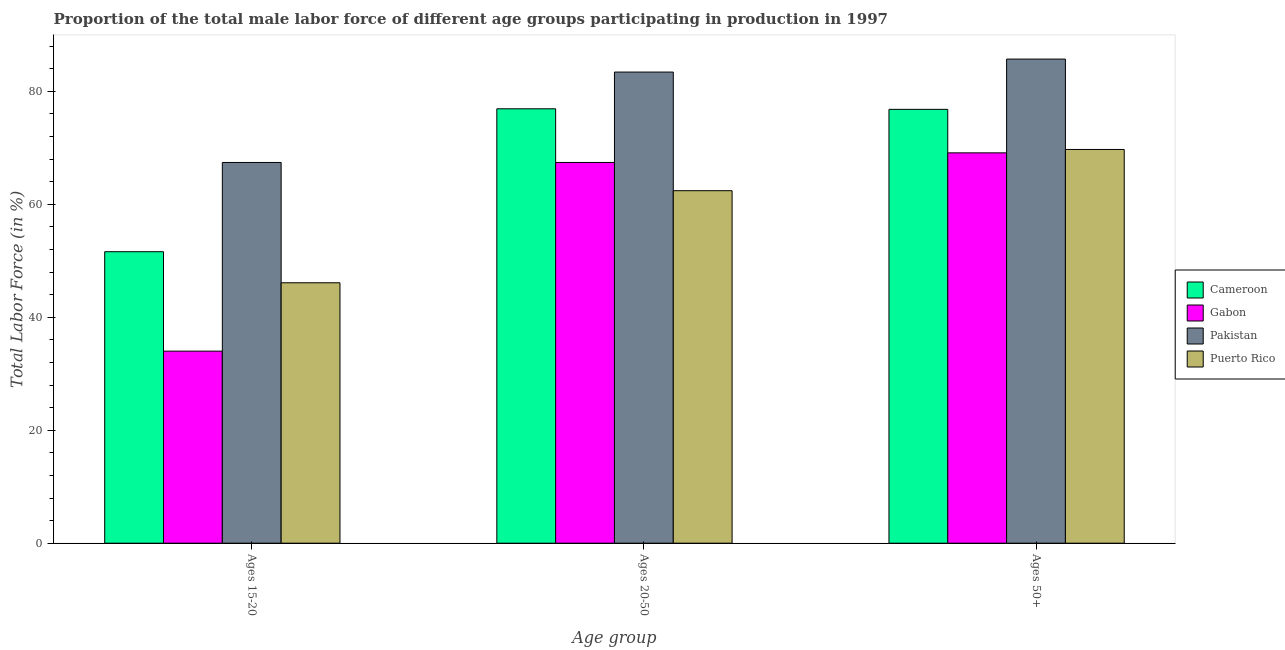How many groups of bars are there?
Provide a succinct answer. 3. What is the label of the 2nd group of bars from the left?
Give a very brief answer. Ages 20-50. What is the percentage of male labor force within the age group 20-50 in Cameroon?
Make the answer very short. 76.9. Across all countries, what is the maximum percentage of male labor force within the age group 15-20?
Give a very brief answer. 67.4. Across all countries, what is the minimum percentage of male labor force within the age group 20-50?
Ensure brevity in your answer.  62.4. In which country was the percentage of male labor force above age 50 minimum?
Give a very brief answer. Gabon. What is the total percentage of male labor force above age 50 in the graph?
Provide a short and direct response. 301.3. What is the difference between the percentage of male labor force within the age group 20-50 in Gabon and that in Puerto Rico?
Provide a short and direct response. 5. What is the difference between the percentage of male labor force within the age group 20-50 in Pakistan and the percentage of male labor force within the age group 15-20 in Puerto Rico?
Keep it short and to the point. 37.3. What is the average percentage of male labor force within the age group 20-50 per country?
Make the answer very short. 72.53. What is the difference between the percentage of male labor force within the age group 15-20 and percentage of male labor force within the age group 20-50 in Cameroon?
Give a very brief answer. -25.3. In how many countries, is the percentage of male labor force within the age group 15-20 greater than 24 %?
Keep it short and to the point. 4. What is the ratio of the percentage of male labor force above age 50 in Gabon to that in Puerto Rico?
Your answer should be compact. 0.99. Is the percentage of male labor force within the age group 20-50 in Pakistan less than that in Cameroon?
Offer a terse response. No. Is the difference between the percentage of male labor force within the age group 15-20 in Cameroon and Pakistan greater than the difference between the percentage of male labor force above age 50 in Cameroon and Pakistan?
Offer a terse response. No. What is the difference between the highest and the second highest percentage of male labor force within the age group 20-50?
Your response must be concise. 6.5. What is the difference between the highest and the lowest percentage of male labor force above age 50?
Offer a terse response. 16.6. In how many countries, is the percentage of male labor force within the age group 15-20 greater than the average percentage of male labor force within the age group 15-20 taken over all countries?
Your answer should be very brief. 2. Is the sum of the percentage of male labor force above age 50 in Pakistan and Gabon greater than the maximum percentage of male labor force within the age group 20-50 across all countries?
Give a very brief answer. Yes. What does the 1st bar from the right in Ages 50+ represents?
Provide a succinct answer. Puerto Rico. Is it the case that in every country, the sum of the percentage of male labor force within the age group 15-20 and percentage of male labor force within the age group 20-50 is greater than the percentage of male labor force above age 50?
Offer a very short reply. Yes. Are all the bars in the graph horizontal?
Give a very brief answer. No. What is the difference between two consecutive major ticks on the Y-axis?
Provide a short and direct response. 20. Does the graph contain grids?
Offer a very short reply. No. What is the title of the graph?
Provide a succinct answer. Proportion of the total male labor force of different age groups participating in production in 1997. Does "Ukraine" appear as one of the legend labels in the graph?
Your answer should be compact. No. What is the label or title of the X-axis?
Your answer should be very brief. Age group. What is the Total Labor Force (in %) of Cameroon in Ages 15-20?
Ensure brevity in your answer.  51.6. What is the Total Labor Force (in %) of Gabon in Ages 15-20?
Offer a terse response. 34. What is the Total Labor Force (in %) of Pakistan in Ages 15-20?
Offer a terse response. 67.4. What is the Total Labor Force (in %) in Puerto Rico in Ages 15-20?
Offer a very short reply. 46.1. What is the Total Labor Force (in %) of Cameroon in Ages 20-50?
Ensure brevity in your answer.  76.9. What is the Total Labor Force (in %) of Gabon in Ages 20-50?
Provide a succinct answer. 67.4. What is the Total Labor Force (in %) of Pakistan in Ages 20-50?
Keep it short and to the point. 83.4. What is the Total Labor Force (in %) in Puerto Rico in Ages 20-50?
Offer a terse response. 62.4. What is the Total Labor Force (in %) of Cameroon in Ages 50+?
Offer a terse response. 76.8. What is the Total Labor Force (in %) of Gabon in Ages 50+?
Offer a very short reply. 69.1. What is the Total Labor Force (in %) in Pakistan in Ages 50+?
Your answer should be very brief. 85.7. What is the Total Labor Force (in %) in Puerto Rico in Ages 50+?
Ensure brevity in your answer.  69.7. Across all Age group, what is the maximum Total Labor Force (in %) of Cameroon?
Provide a short and direct response. 76.9. Across all Age group, what is the maximum Total Labor Force (in %) in Gabon?
Ensure brevity in your answer.  69.1. Across all Age group, what is the maximum Total Labor Force (in %) of Pakistan?
Offer a terse response. 85.7. Across all Age group, what is the maximum Total Labor Force (in %) in Puerto Rico?
Your response must be concise. 69.7. Across all Age group, what is the minimum Total Labor Force (in %) in Cameroon?
Provide a succinct answer. 51.6. Across all Age group, what is the minimum Total Labor Force (in %) of Gabon?
Give a very brief answer. 34. Across all Age group, what is the minimum Total Labor Force (in %) in Pakistan?
Offer a very short reply. 67.4. Across all Age group, what is the minimum Total Labor Force (in %) of Puerto Rico?
Provide a succinct answer. 46.1. What is the total Total Labor Force (in %) in Cameroon in the graph?
Offer a terse response. 205.3. What is the total Total Labor Force (in %) of Gabon in the graph?
Ensure brevity in your answer.  170.5. What is the total Total Labor Force (in %) of Pakistan in the graph?
Provide a succinct answer. 236.5. What is the total Total Labor Force (in %) of Puerto Rico in the graph?
Keep it short and to the point. 178.2. What is the difference between the Total Labor Force (in %) of Cameroon in Ages 15-20 and that in Ages 20-50?
Offer a terse response. -25.3. What is the difference between the Total Labor Force (in %) of Gabon in Ages 15-20 and that in Ages 20-50?
Provide a short and direct response. -33.4. What is the difference between the Total Labor Force (in %) in Puerto Rico in Ages 15-20 and that in Ages 20-50?
Your answer should be compact. -16.3. What is the difference between the Total Labor Force (in %) in Cameroon in Ages 15-20 and that in Ages 50+?
Keep it short and to the point. -25.2. What is the difference between the Total Labor Force (in %) of Gabon in Ages 15-20 and that in Ages 50+?
Your response must be concise. -35.1. What is the difference between the Total Labor Force (in %) of Pakistan in Ages 15-20 and that in Ages 50+?
Offer a terse response. -18.3. What is the difference between the Total Labor Force (in %) of Puerto Rico in Ages 15-20 and that in Ages 50+?
Your answer should be compact. -23.6. What is the difference between the Total Labor Force (in %) of Cameroon in Ages 20-50 and that in Ages 50+?
Make the answer very short. 0.1. What is the difference between the Total Labor Force (in %) of Gabon in Ages 20-50 and that in Ages 50+?
Offer a very short reply. -1.7. What is the difference between the Total Labor Force (in %) in Puerto Rico in Ages 20-50 and that in Ages 50+?
Give a very brief answer. -7.3. What is the difference between the Total Labor Force (in %) of Cameroon in Ages 15-20 and the Total Labor Force (in %) of Gabon in Ages 20-50?
Ensure brevity in your answer.  -15.8. What is the difference between the Total Labor Force (in %) of Cameroon in Ages 15-20 and the Total Labor Force (in %) of Pakistan in Ages 20-50?
Ensure brevity in your answer.  -31.8. What is the difference between the Total Labor Force (in %) in Cameroon in Ages 15-20 and the Total Labor Force (in %) in Puerto Rico in Ages 20-50?
Ensure brevity in your answer.  -10.8. What is the difference between the Total Labor Force (in %) in Gabon in Ages 15-20 and the Total Labor Force (in %) in Pakistan in Ages 20-50?
Your response must be concise. -49.4. What is the difference between the Total Labor Force (in %) in Gabon in Ages 15-20 and the Total Labor Force (in %) in Puerto Rico in Ages 20-50?
Your response must be concise. -28.4. What is the difference between the Total Labor Force (in %) of Pakistan in Ages 15-20 and the Total Labor Force (in %) of Puerto Rico in Ages 20-50?
Your answer should be very brief. 5. What is the difference between the Total Labor Force (in %) of Cameroon in Ages 15-20 and the Total Labor Force (in %) of Gabon in Ages 50+?
Offer a terse response. -17.5. What is the difference between the Total Labor Force (in %) in Cameroon in Ages 15-20 and the Total Labor Force (in %) in Pakistan in Ages 50+?
Make the answer very short. -34.1. What is the difference between the Total Labor Force (in %) in Cameroon in Ages 15-20 and the Total Labor Force (in %) in Puerto Rico in Ages 50+?
Provide a short and direct response. -18.1. What is the difference between the Total Labor Force (in %) of Gabon in Ages 15-20 and the Total Labor Force (in %) of Pakistan in Ages 50+?
Your answer should be very brief. -51.7. What is the difference between the Total Labor Force (in %) of Gabon in Ages 15-20 and the Total Labor Force (in %) of Puerto Rico in Ages 50+?
Give a very brief answer. -35.7. What is the difference between the Total Labor Force (in %) in Pakistan in Ages 15-20 and the Total Labor Force (in %) in Puerto Rico in Ages 50+?
Keep it short and to the point. -2.3. What is the difference between the Total Labor Force (in %) of Cameroon in Ages 20-50 and the Total Labor Force (in %) of Gabon in Ages 50+?
Ensure brevity in your answer.  7.8. What is the difference between the Total Labor Force (in %) of Cameroon in Ages 20-50 and the Total Labor Force (in %) of Pakistan in Ages 50+?
Your answer should be compact. -8.8. What is the difference between the Total Labor Force (in %) of Gabon in Ages 20-50 and the Total Labor Force (in %) of Pakistan in Ages 50+?
Provide a short and direct response. -18.3. What is the average Total Labor Force (in %) in Cameroon per Age group?
Provide a succinct answer. 68.43. What is the average Total Labor Force (in %) of Gabon per Age group?
Provide a succinct answer. 56.83. What is the average Total Labor Force (in %) of Pakistan per Age group?
Provide a short and direct response. 78.83. What is the average Total Labor Force (in %) in Puerto Rico per Age group?
Offer a terse response. 59.4. What is the difference between the Total Labor Force (in %) of Cameroon and Total Labor Force (in %) of Pakistan in Ages 15-20?
Your answer should be very brief. -15.8. What is the difference between the Total Labor Force (in %) in Gabon and Total Labor Force (in %) in Pakistan in Ages 15-20?
Your answer should be compact. -33.4. What is the difference between the Total Labor Force (in %) of Gabon and Total Labor Force (in %) of Puerto Rico in Ages 15-20?
Offer a terse response. -12.1. What is the difference between the Total Labor Force (in %) of Pakistan and Total Labor Force (in %) of Puerto Rico in Ages 15-20?
Provide a short and direct response. 21.3. What is the difference between the Total Labor Force (in %) in Gabon and Total Labor Force (in %) in Pakistan in Ages 50+?
Provide a succinct answer. -16.6. What is the difference between the Total Labor Force (in %) of Gabon and Total Labor Force (in %) of Puerto Rico in Ages 50+?
Provide a short and direct response. -0.6. What is the difference between the Total Labor Force (in %) in Pakistan and Total Labor Force (in %) in Puerto Rico in Ages 50+?
Provide a succinct answer. 16. What is the ratio of the Total Labor Force (in %) of Cameroon in Ages 15-20 to that in Ages 20-50?
Keep it short and to the point. 0.67. What is the ratio of the Total Labor Force (in %) of Gabon in Ages 15-20 to that in Ages 20-50?
Offer a very short reply. 0.5. What is the ratio of the Total Labor Force (in %) of Pakistan in Ages 15-20 to that in Ages 20-50?
Offer a very short reply. 0.81. What is the ratio of the Total Labor Force (in %) in Puerto Rico in Ages 15-20 to that in Ages 20-50?
Offer a terse response. 0.74. What is the ratio of the Total Labor Force (in %) in Cameroon in Ages 15-20 to that in Ages 50+?
Keep it short and to the point. 0.67. What is the ratio of the Total Labor Force (in %) in Gabon in Ages 15-20 to that in Ages 50+?
Offer a very short reply. 0.49. What is the ratio of the Total Labor Force (in %) of Pakistan in Ages 15-20 to that in Ages 50+?
Keep it short and to the point. 0.79. What is the ratio of the Total Labor Force (in %) of Puerto Rico in Ages 15-20 to that in Ages 50+?
Your answer should be compact. 0.66. What is the ratio of the Total Labor Force (in %) of Cameroon in Ages 20-50 to that in Ages 50+?
Give a very brief answer. 1. What is the ratio of the Total Labor Force (in %) of Gabon in Ages 20-50 to that in Ages 50+?
Give a very brief answer. 0.98. What is the ratio of the Total Labor Force (in %) in Pakistan in Ages 20-50 to that in Ages 50+?
Offer a terse response. 0.97. What is the ratio of the Total Labor Force (in %) in Puerto Rico in Ages 20-50 to that in Ages 50+?
Make the answer very short. 0.9. What is the difference between the highest and the second highest Total Labor Force (in %) of Cameroon?
Give a very brief answer. 0.1. What is the difference between the highest and the second highest Total Labor Force (in %) of Puerto Rico?
Provide a short and direct response. 7.3. What is the difference between the highest and the lowest Total Labor Force (in %) of Cameroon?
Offer a terse response. 25.3. What is the difference between the highest and the lowest Total Labor Force (in %) in Gabon?
Offer a terse response. 35.1. What is the difference between the highest and the lowest Total Labor Force (in %) of Puerto Rico?
Your answer should be compact. 23.6. 